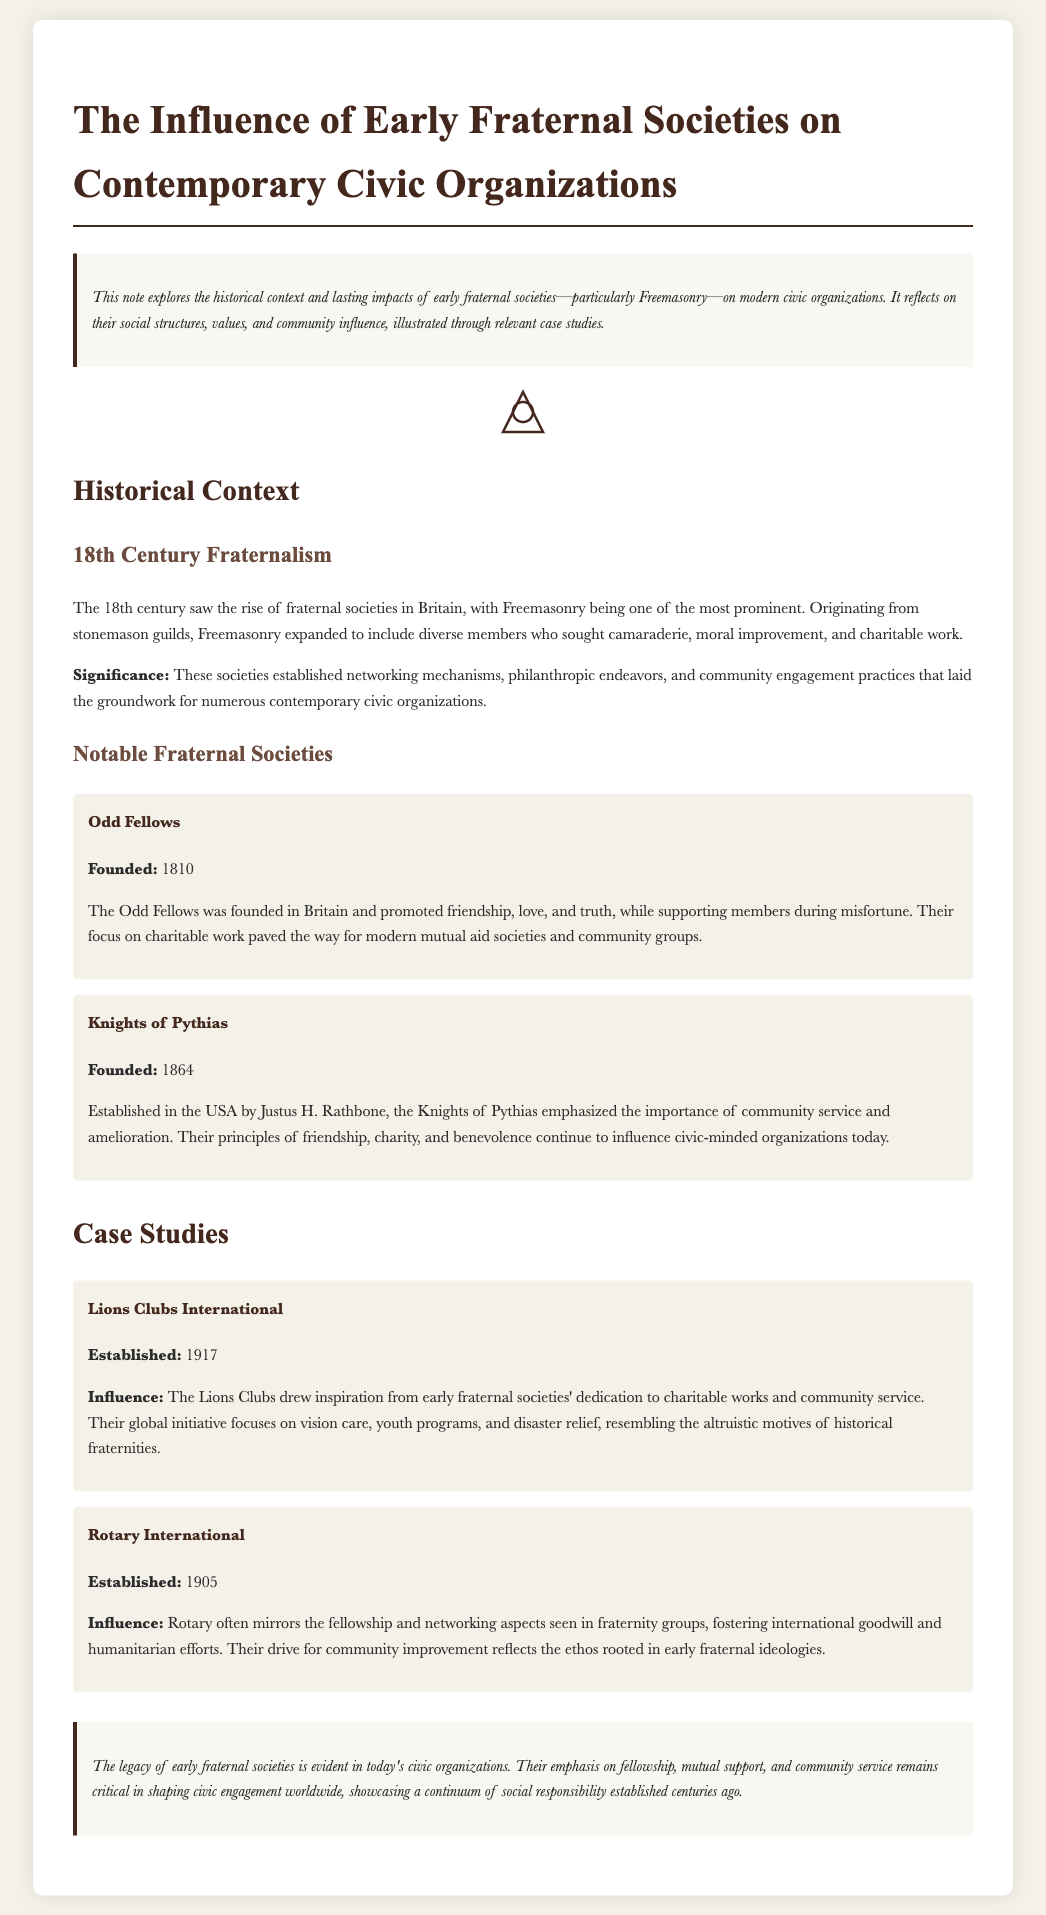What is the primary focus of the note? The note explores the historical context and lasting impacts of early fraternal societies on modern civic organizations.
Answer: Historical context and lasting impacts When was the Odd Fellows founded? The founding date of the Odd Fellows is mentioned in the document.
Answer: 1810 What significant principle influenced the Knights of Pythias? The Knights of Pythias emphasized the importance of community service and amelioration.
Answer: Community service What year was Rotary International established? The establishment date of Rotary International is provided in the case studies section of the document.
Answer: 1905 What type of initiatives do Lions Clubs focus on? The Lions Clubs focus on vision care, youth programs, and disaster relief, inspired by early fraternal societies.
Answer: Vision care, youth programs, and disaster relief What is a notable legacy of early fraternal societies according to the conclusion? The conclusion highlights the importance of fellowship, mutual support, and community service as a legacy.
Answer: Fellowship, mutual support, and community service Which fraternal society was founded in 1864? The document lists the founding year of the Knights of Pythias as 1864.
Answer: Knights of Pythias What is a defining characteristic of Rotary International, according to the document? The document mentions that Rotary mirrors the fellowship and networking aspects of fraternity groups.
Answer: Fellowship and networking What type of document is this note classified as? The text presents a structured exploration of fraternal societies and their influence on civic organizations.
Answer: Note 